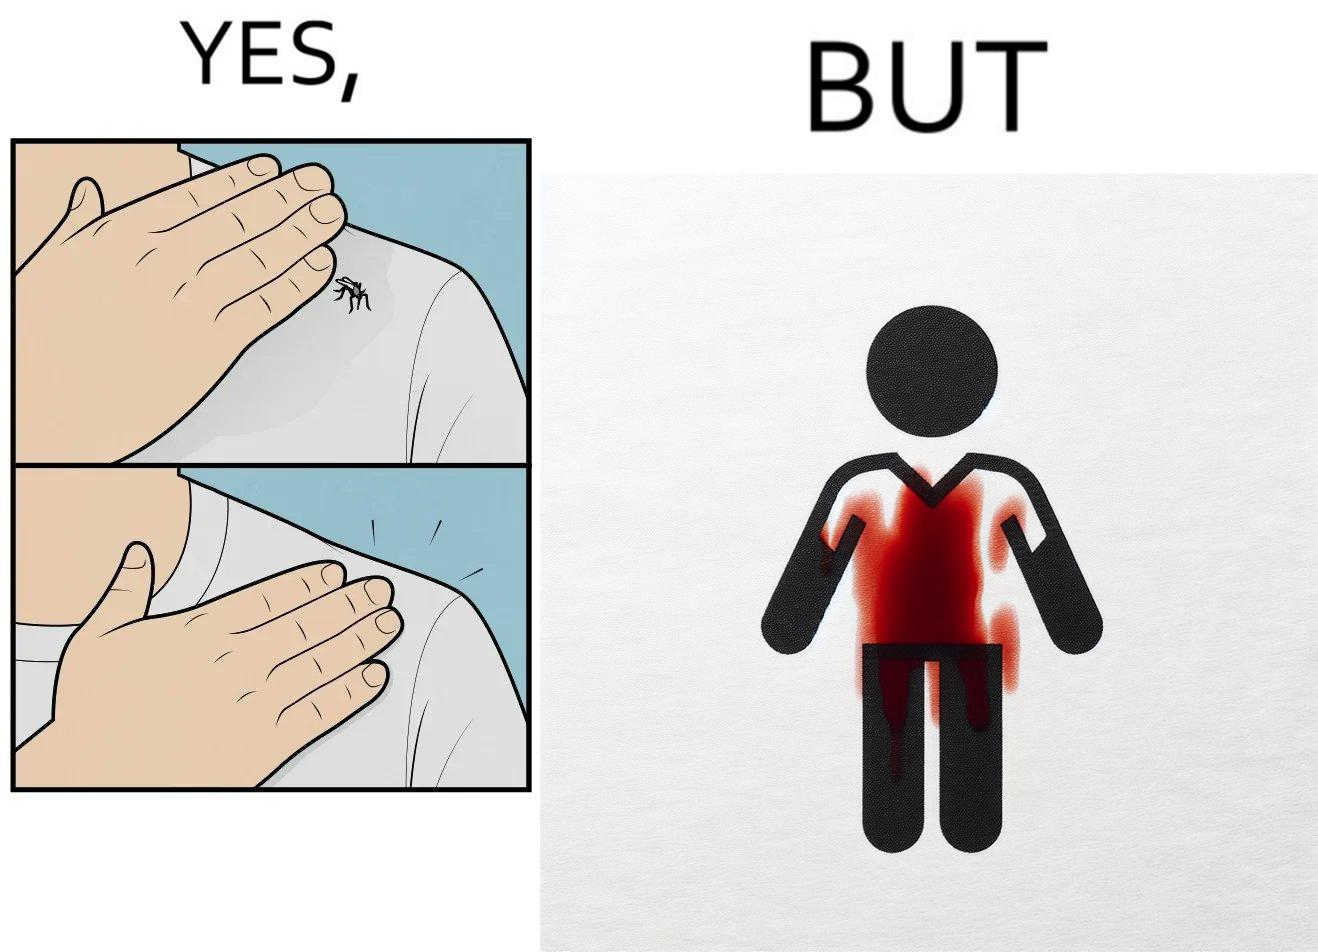Describe the contrast between the left and right parts of this image. In the left part of the image: It is a set of two images of a man killing a mosquito by hand. In the right part of the image: It is man with red liquid smeared on his t-shirt 